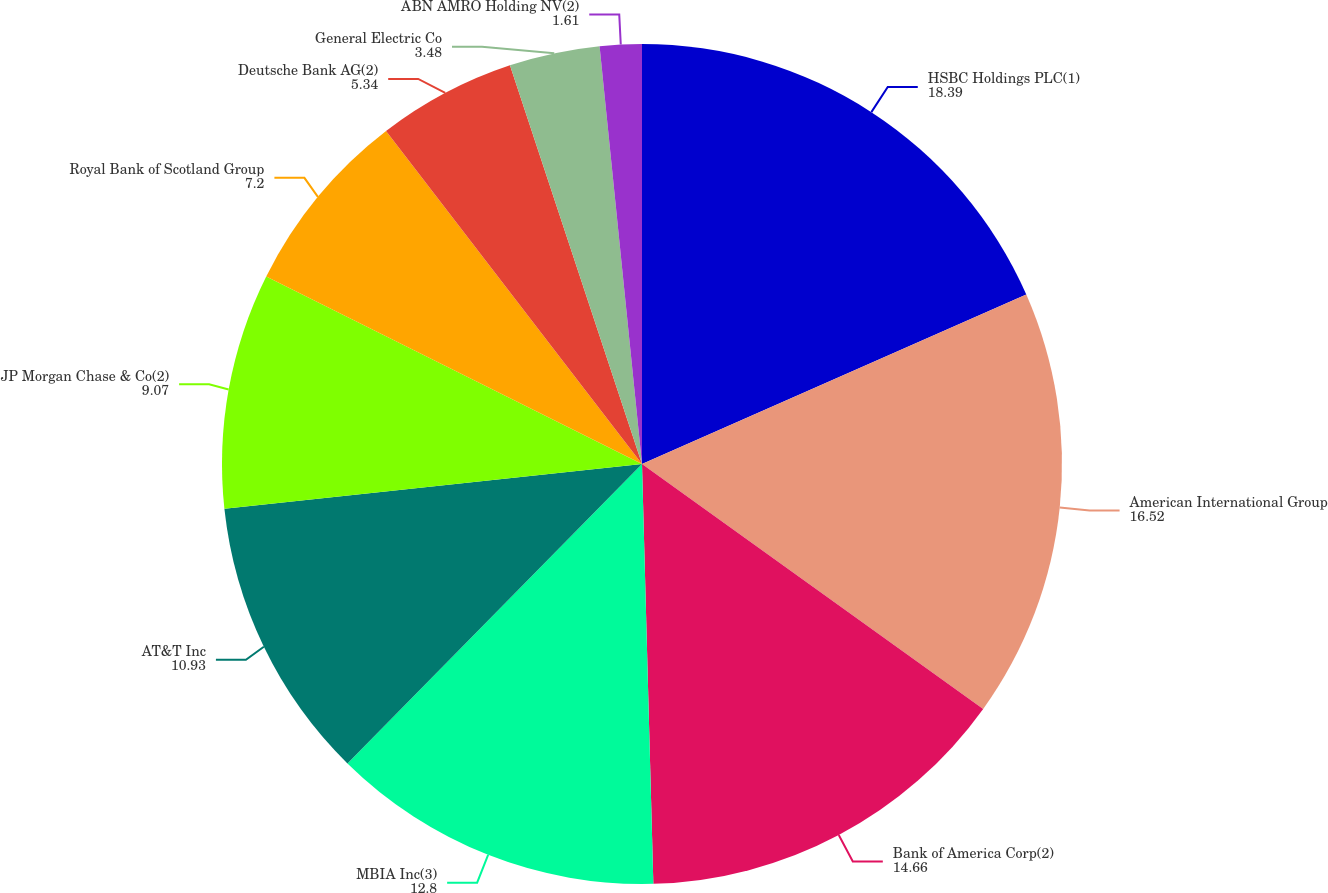Convert chart. <chart><loc_0><loc_0><loc_500><loc_500><pie_chart><fcel>HSBC Holdings PLC(1)<fcel>American International Group<fcel>Bank of America Corp(2)<fcel>MBIA Inc(3)<fcel>AT&T Inc<fcel>JP Morgan Chase & Co(2)<fcel>Royal Bank of Scotland Group<fcel>Deutsche Bank AG(2)<fcel>General Electric Co<fcel>ABN AMRO Holding NV(2)<nl><fcel>18.39%<fcel>16.52%<fcel>14.66%<fcel>12.8%<fcel>10.93%<fcel>9.07%<fcel>7.2%<fcel>5.34%<fcel>3.48%<fcel>1.61%<nl></chart> 